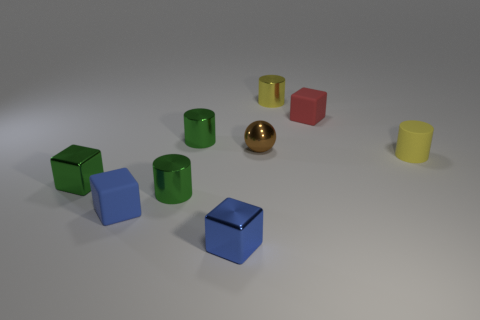Subtract all tiny yellow shiny cylinders. How many cylinders are left? 3 Subtract 1 spheres. How many spheres are left? 0 Subtract all blue cubes. How many cubes are left? 2 Add 9 tiny yellow rubber cylinders. How many tiny yellow rubber cylinders are left? 10 Add 7 big cyan things. How many big cyan things exist? 7 Subtract 1 yellow cylinders. How many objects are left? 8 Subtract all spheres. How many objects are left? 8 Subtract all brown blocks. Subtract all cyan balls. How many blocks are left? 4 Subtract all blue spheres. How many blue blocks are left? 2 Subtract all tiny cubes. Subtract all balls. How many objects are left? 4 